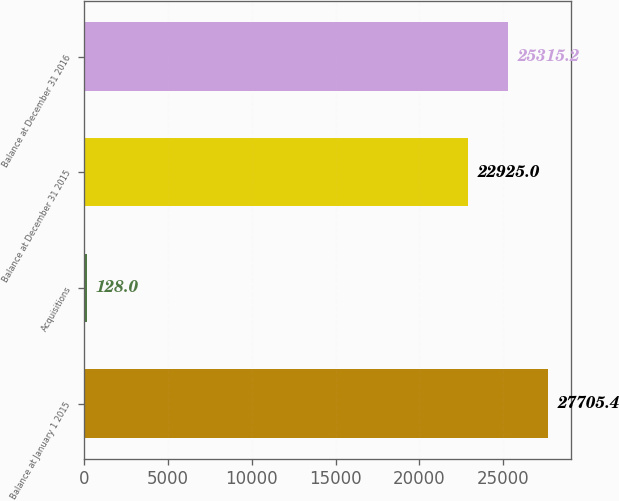Convert chart. <chart><loc_0><loc_0><loc_500><loc_500><bar_chart><fcel>Balance at January 1 2015<fcel>Acquisitions<fcel>Balance at December 31 2015<fcel>Balance at December 31 2016<nl><fcel>27705.4<fcel>128<fcel>22925<fcel>25315.2<nl></chart> 